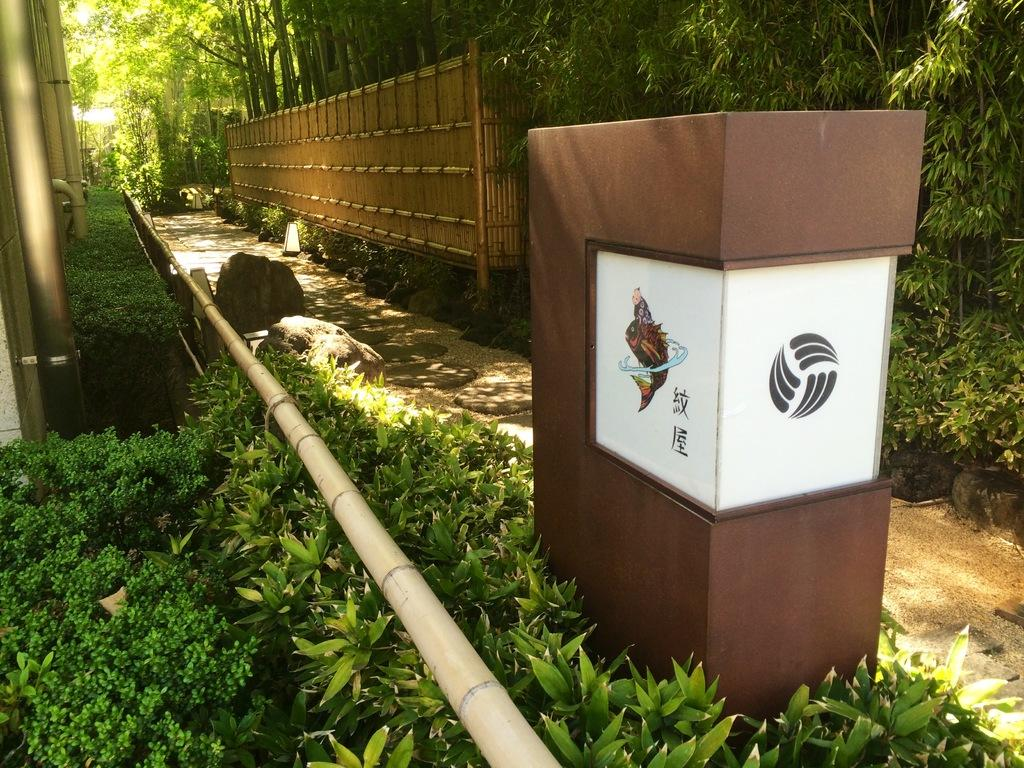What type of vegetation can be seen in the image? There are plants and trees in the image. What kind of barrier is present in the image? There is a fence in the image. Are there any man-made structures visible in the image? Yes, there are pipes in the image. What material is used to create the wooden object in the image? The wooden object in the image is made of wood. What type of cracker is being used to hold the pipes together in the image? There is no cracker present in the image, nor are the pipes being held together by any cracker. 